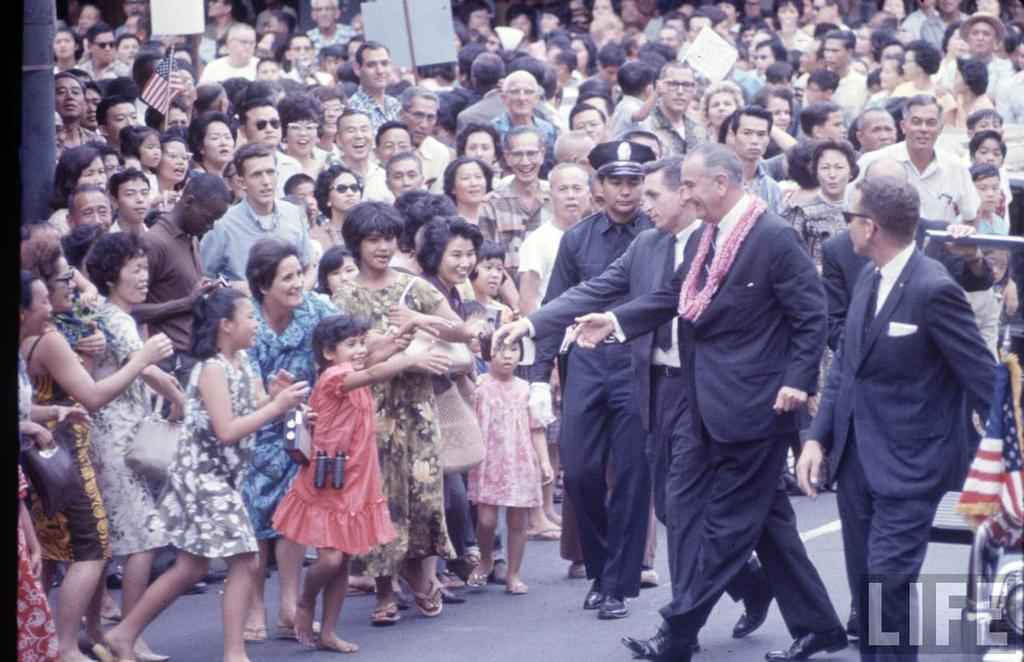What is happening in the image? There is a group of people in the image. What are the people doing in the image? The people are walking on a road. What can be seen in the background of the image? There is a building in the background of the image. What is the tendency of the children in the image? There are no children mentioned in the image, only a group of people. 